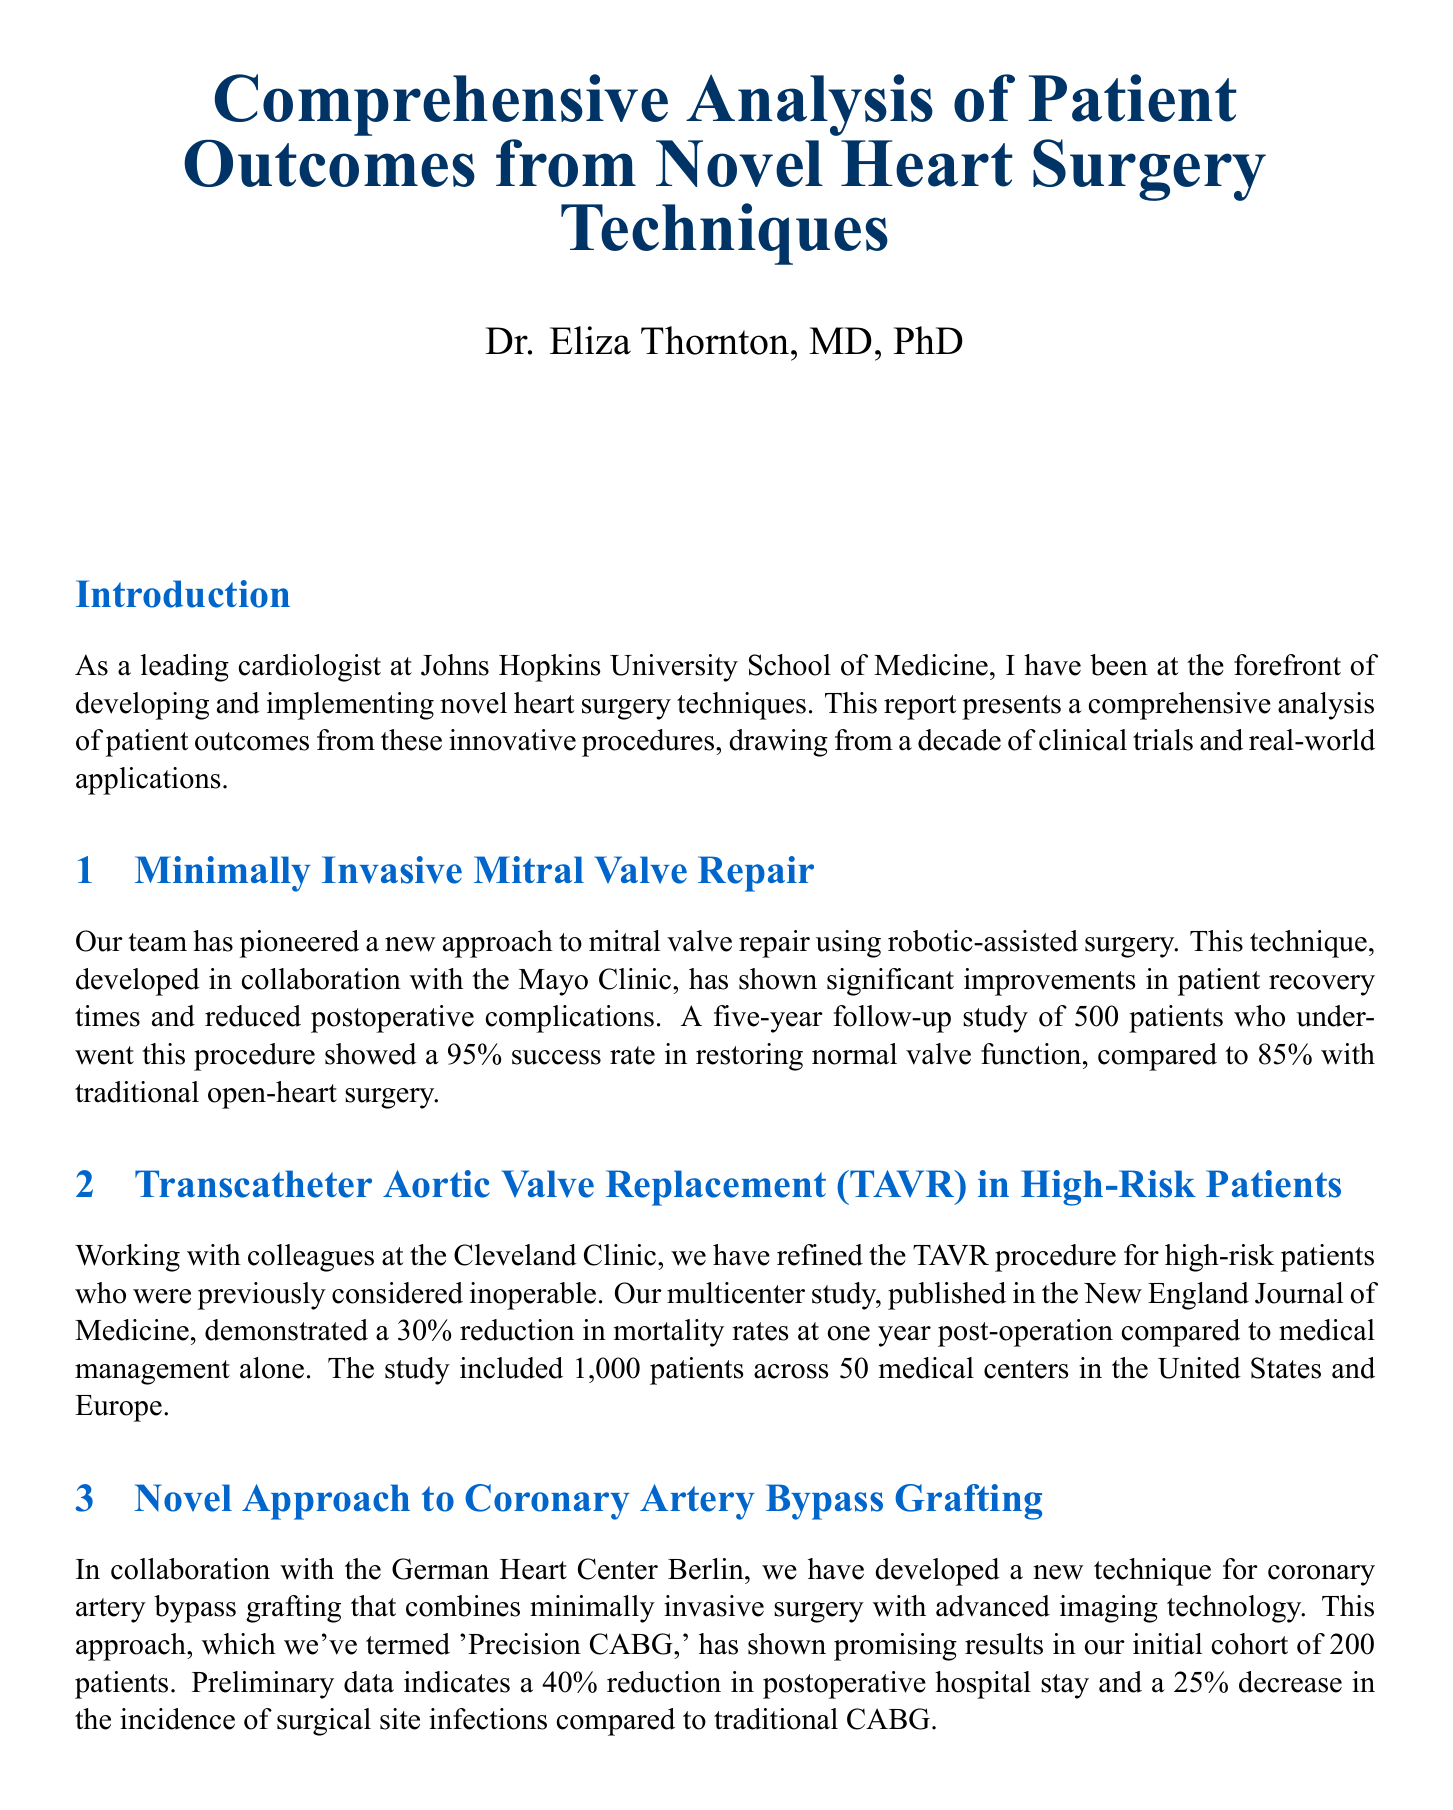What is the title of the report? The title of the report is found at the beginning of the document.
Answer: Comprehensive Analysis of Patient Outcomes from Novel Heart Surgery Techniques Who is the author of the report? The author is mentioned just below the title in the document.
Answer: Dr. Eliza Thornton, MD, PhD What is the success rate of minimally invasive mitral valve repair? The success rate is stated in the section about minimally invasive mitral valve repair.
Answer: 95% How many patients were included in the TAVR study? The document specifies the number of patients studied in the TAVR section.
Answer: 1,000 patients What is the percentage reduction in hospital stay with Precision CABG? This percentage is presented in the section regarding the novel approach to coronary artery bypass grafting.
Answer: 40% What has been the impact on pump thrombosis rates with the HeartMate 3 LVAD? This impact is described in the section on long-term outcomes of LVADs.
Answer: 50% reduction What type of analysis was conducted in partnership with the Wharton School? The document describes the analysis type in the section on economic impact.
Answer: Cost-effectiveness analysis What is the estimated net savings per patient over five years? The estimated savings is noted in the economic impact section of the document.
Answer: $50,000 